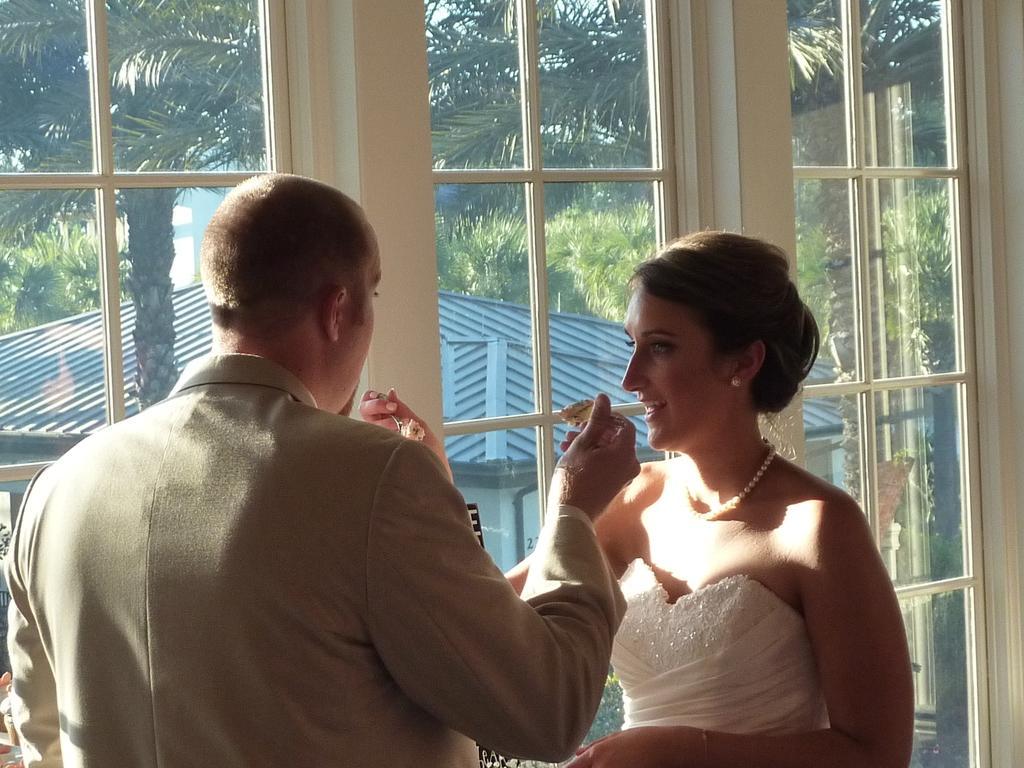Could you give a brief overview of what you see in this image? In this image we can see a man and a woman holding the spoon of food. In the background, we can see the glass window and through the glass window we can see the trees and also the roof house. 